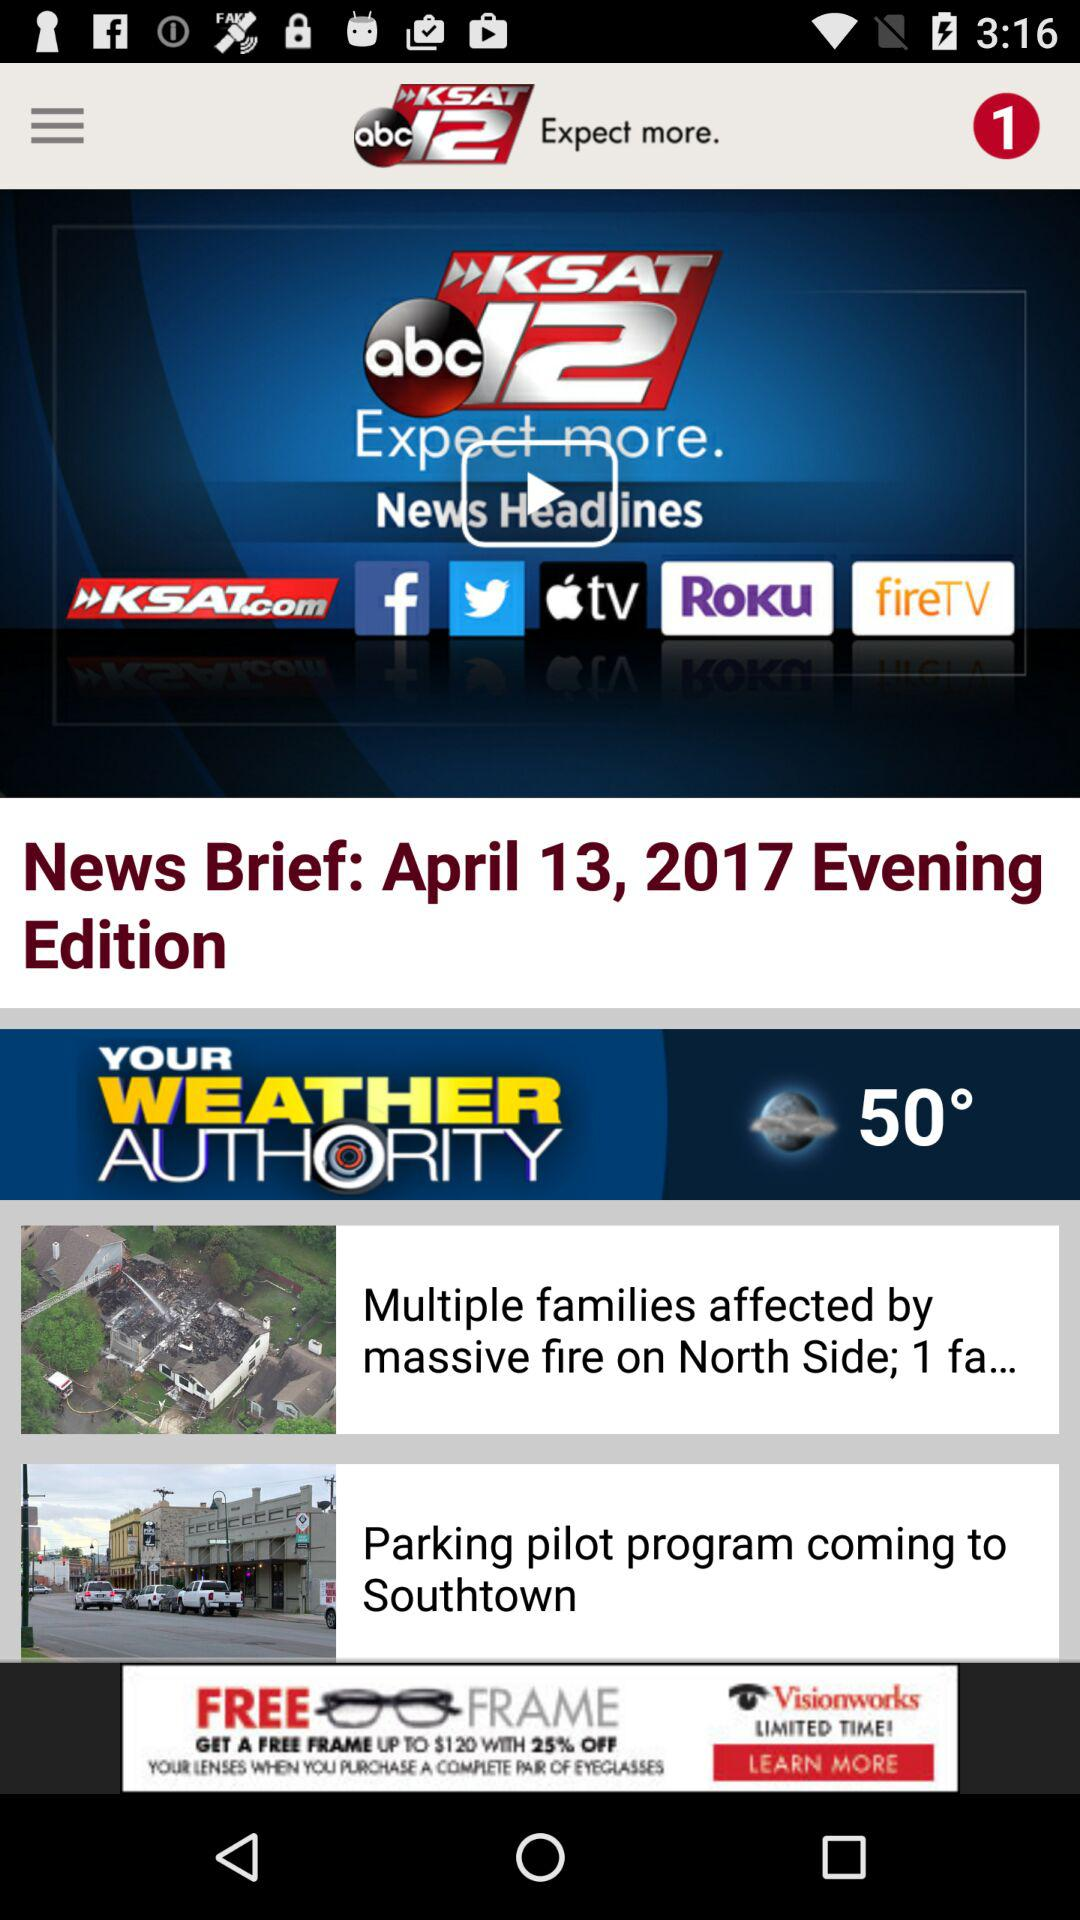What is the temperature? The temperature is 50°. 